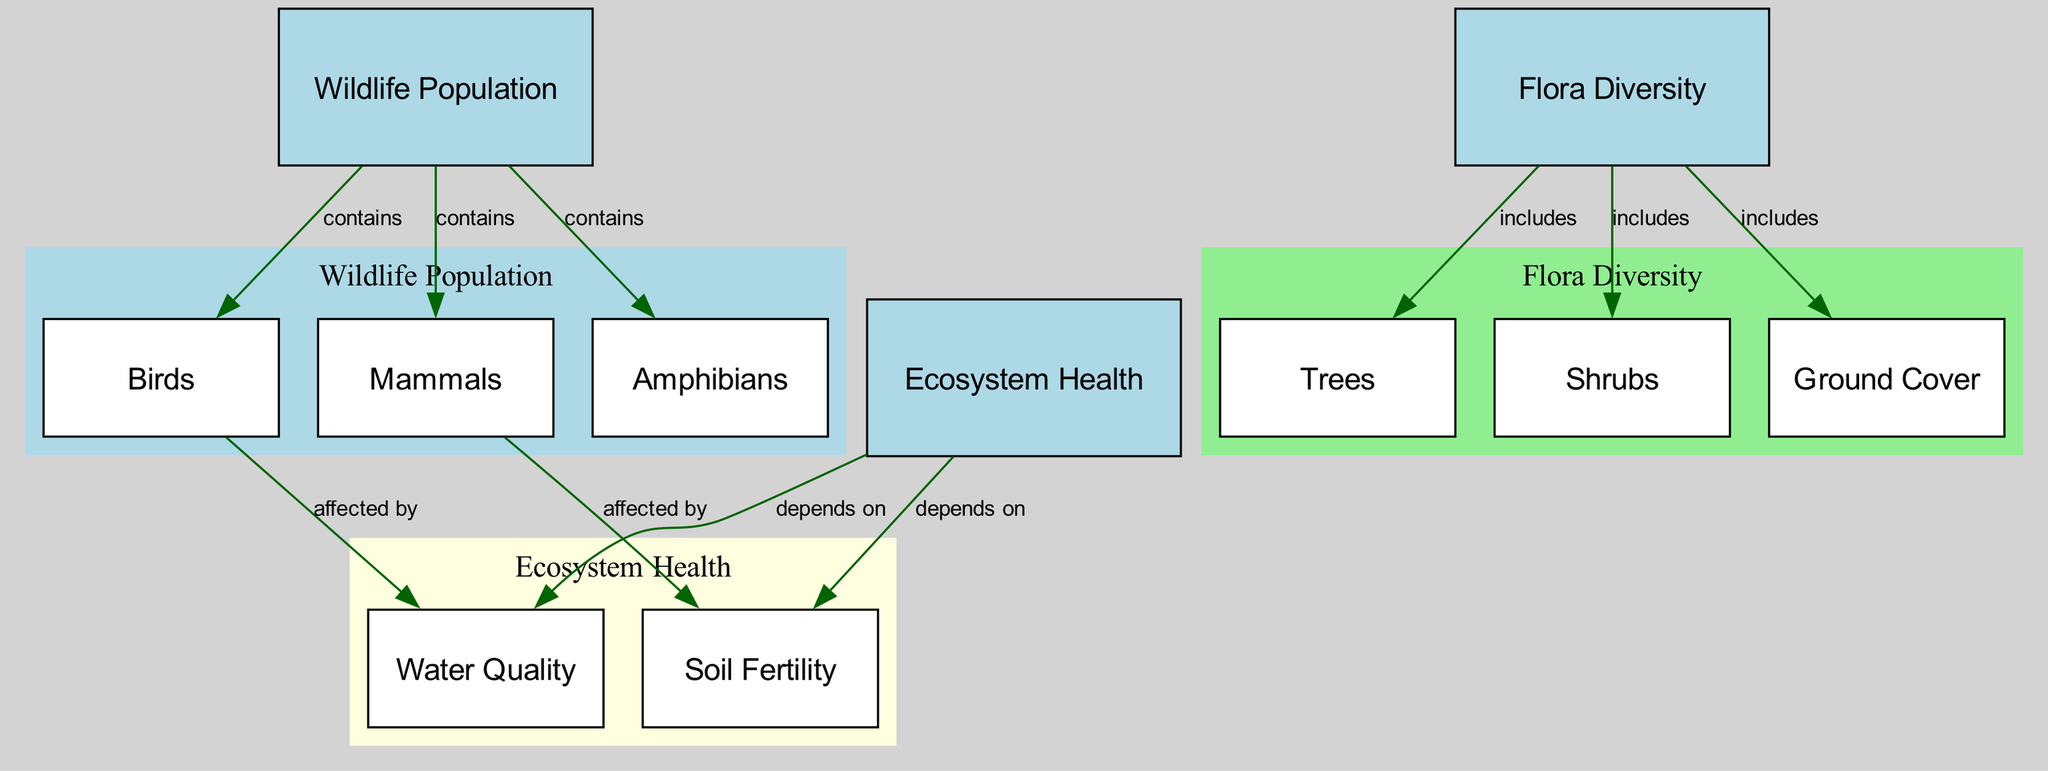What are the three main categories depicted in the diagram? The diagram displays three main categories: Wildlife Population, Flora Diversity, and Ecosystem Health, each represented as a separate category node.
Answer: Wildlife Population, Flora Diversity, Ecosystem Health How many subcategories are included under Flora Diversity? Flora Diversity includes three subcategories: Trees, Shrubs, and Ground Cover. By counting these nodes under Flora Diversity, the answer is determined.
Answer: 3 Which subcategory is affected by mammals? The relationship from Mammals to Soil Fertility indicates that Soil Fertility is the subcategory affected by mammals as per the directed edge label.
Answer: Soil Fertility What does the Wildlife Population category contain? The Wildlife Population category contains three subcategories: Birds, Mammals, and Amphibians. This is identified by the edges emanating from the Wildlife Population node that connect to these subcategories.
Answer: Birds, Mammals, Amphibians How does ecosystem health relate to water quality? Ecosystem Health depends on Water Quality, as indicated by the directed edge connecting these two categories, showing a dependency relationship.
Answer: depends on What color represents the Flora Diversity category in the diagram? In the diagram, the Flora Diversity category is represented by a filled color of light green, which can be seen in the subgraph's attributes.
Answer: light green Which category includes trees as a subcategory? Trees belong to the Flora Diversity category, as indicated by the edge linking Flora Diversity to the Trees subcategory.
Answer: Flora Diversity What relationship do birds have with water quality? The diagram shows that Birds are affected by Water Quality, depicted by the directed edge leading from Birds to Water Quality with the corresponding label.
Answer: affected by What type of diagram is represented here? This diagram is a Natural Science Diagram, which focuses on depicting ecological relationships and biodiversity, clearly defining categories and their interconnections.
Answer: Natural Science Diagram 